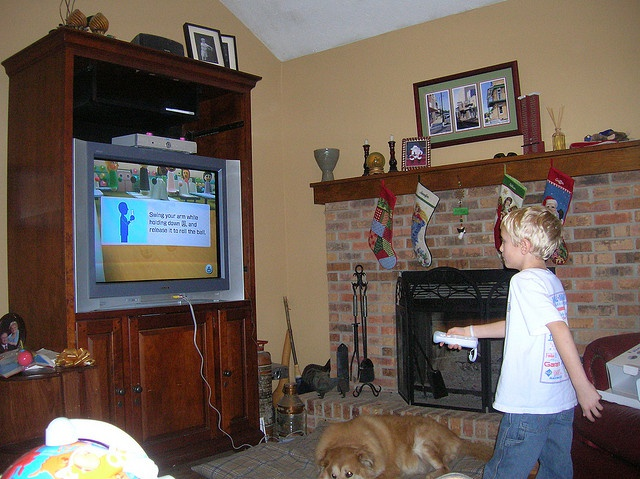Describe the objects in this image and their specific colors. I can see tv in gray, blue, and olive tones, people in gray, white, and pink tones, couch in gray, black, maroon, and darkgray tones, dog in gray and maroon tones, and chair in gray, black, maroon, and purple tones in this image. 